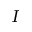Convert formula to latex. <formula><loc_0><loc_0><loc_500><loc_500>I</formula> 